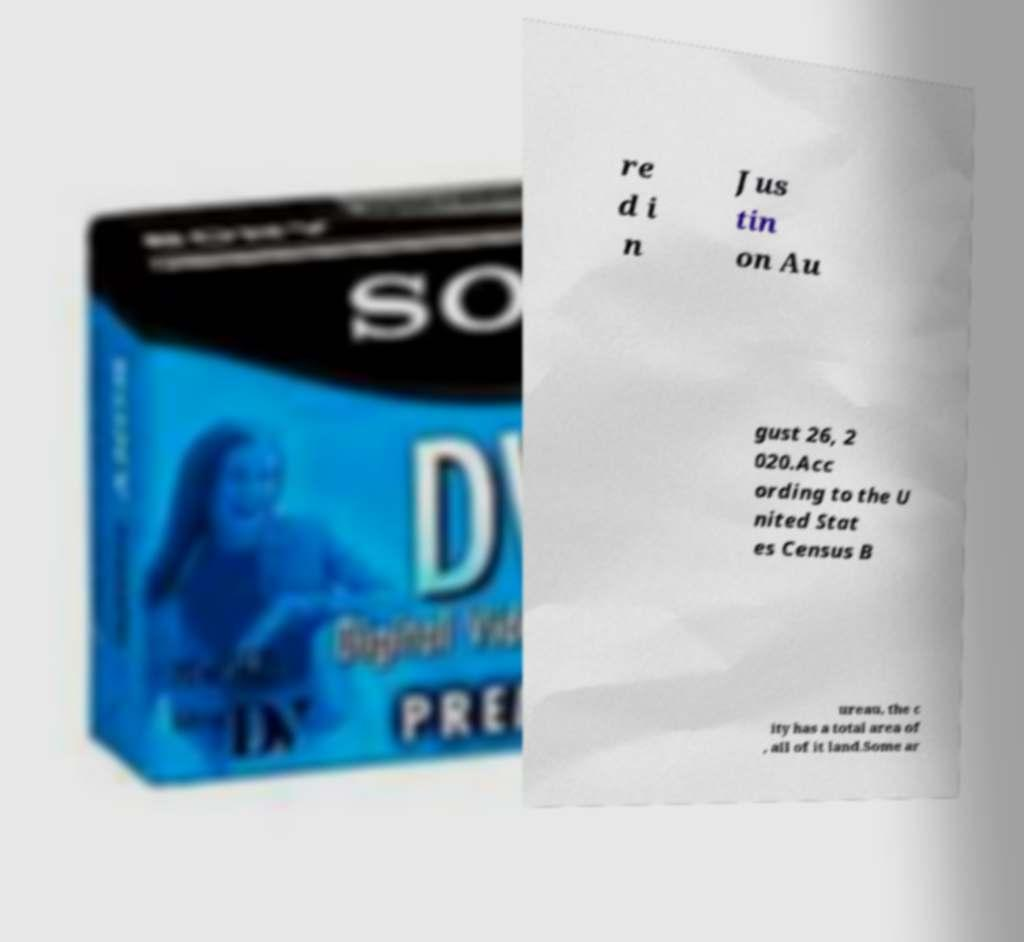Please read and relay the text visible in this image. What does it say? re d i n Jus tin on Au gust 26, 2 020.Acc ording to the U nited Stat es Census B ureau, the c ity has a total area of , all of it land.Some ar 